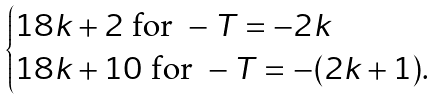<formula> <loc_0><loc_0><loc_500><loc_500>\begin{cases} 1 8 k + 2 \text { for } - T = - 2 k \\ 1 8 k + 1 0 \text { for } - T = - ( 2 k + 1 ) . \end{cases}</formula> 